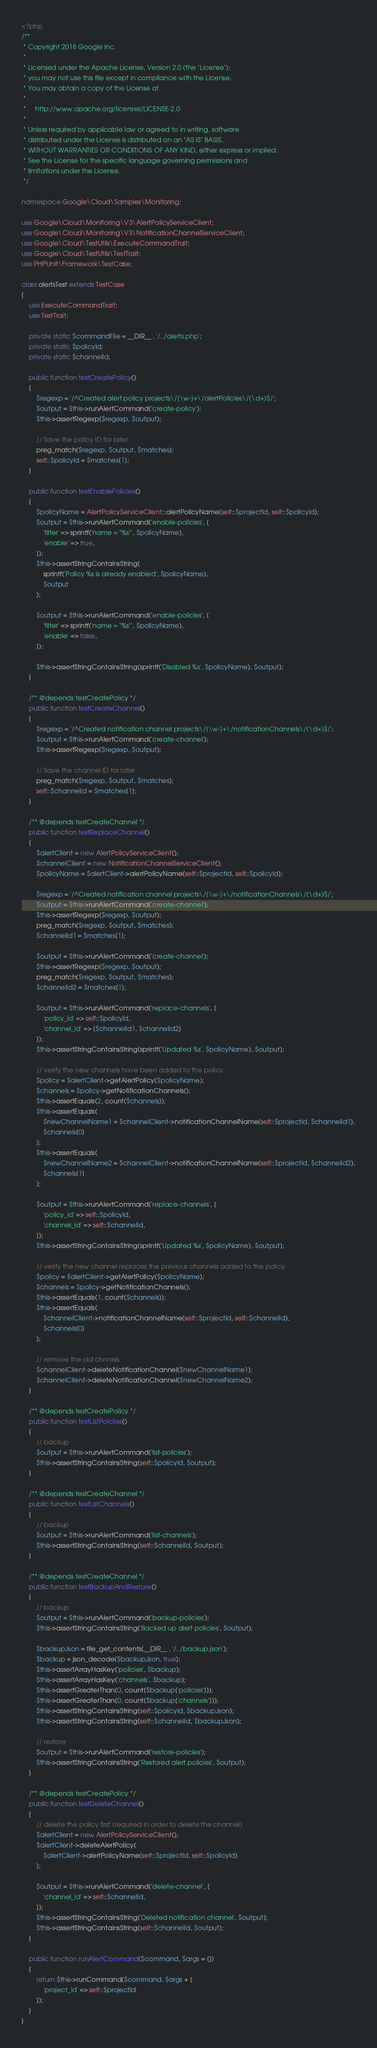<code> <loc_0><loc_0><loc_500><loc_500><_PHP_><?php
/**
 * Copyright 2018 Google Inc.
 *
 * Licensed under the Apache License, Version 2.0 (the "License");
 * you may not use this file except in compliance with the License.
 * You may obtain a copy of the License at
 *
 *     http://www.apache.org/licenses/LICENSE-2.0
 *
 * Unless required by applicable law or agreed to in writing, software
 * distributed under the License is distributed on an "AS IS" BASIS,
 * WITHOUT WARRANTIES OR CONDITIONS OF ANY KIND, either express or implied.
 * See the License for the specific language governing permissions and
 * limitations under the License.
 */

namespace Google\Cloud\Samples\Monitoring;

use Google\Cloud\Monitoring\V3\AlertPolicyServiceClient;
use Google\Cloud\Monitoring\V3\NotificationChannelServiceClient;
use Google\Cloud\TestUtils\ExecuteCommandTrait;
use Google\Cloud\TestUtils\TestTrait;
use PHPUnit\Framework\TestCase;

class alertsTest extends TestCase
{
    use ExecuteCommandTrait;
    use TestTrait;

    private static $commandFile = __DIR__ . '/../alerts.php';
    private static $policyId;
    private static $channelId;

    public function testCreatePolicy()
    {
        $regexp = '/^Created alert policy projects\/[\w-]+\/alertPolicies\/(\d+)$/';
        $output = $this->runAlertCommand('create-policy');
        $this->assertRegexp($regexp, $output);

        // Save the policy ID for later
        preg_match($regexp, $output, $matches);
        self::$policyId = $matches[1];
    }

    public function testEnablePolicies()
    {
        $policyName = AlertPolicyServiceClient::alertPolicyName(self::$projectId, self::$policyId);
        $output = $this->runAlertCommand('enable-policies', [
            'filter' => sprintf('name = "%s"', $policyName),
            'enable' => true,
        ]);
        $this->assertStringContainsString(
            sprintf('Policy %s is already enabled', $policyName),
            $output
        );

        $output = $this->runAlertCommand('enable-policies', [
            'filter' => sprintf('name = "%s"', $policyName),
            'enable' => false,
        ]);

        $this->assertStringContainsString(sprintf('Disabled %s', $policyName), $output);
    }

    /** @depends testCreatePolicy */
    public function testCreateChannel()
    {
        $regexp = '/^Created notification channel projects\/[\w-]+\/notificationChannels\/(\d+)$/';
        $output = $this->runAlertCommand('create-channel');
        $this->assertRegexp($regexp, $output);

        // Save the channel ID for later
        preg_match($regexp, $output, $matches);
        self::$channelId = $matches[1];
    }

    /** @depends testCreateChannel */
    public function testReplaceChannel()
    {
        $alertClient = new AlertPolicyServiceClient();
        $channelClient = new NotificationChannelServiceClient();
        $policyName = $alertClient->alertPolicyName(self::$projectId, self::$policyId);

        $regexp = '/^Created notification channel projects\/[\w-]+\/notificationChannels\/(\d+)$/';
        $output = $this->runAlertCommand('create-channel');
        $this->assertRegexp($regexp, $output);
        preg_match($regexp, $output, $matches);
        $channelId1 = $matches[1];

        $output = $this->runAlertCommand('create-channel');
        $this->assertRegexp($regexp, $output);
        preg_match($regexp, $output, $matches);
        $channelId2 = $matches[1];

        $output = $this->runAlertCommand('replace-channels', [
            'policy_id' => self::$policyId,
            'channel_id' => [$channelId1, $channelId2]
        ]);
        $this->assertStringContainsString(sprintf('Updated %s', $policyName), $output);

        // verify the new channels have been added to the policy
        $policy = $alertClient->getAlertPolicy($policyName);
        $channels = $policy->getNotificationChannels();
        $this->assertEquals(2, count($channels));
        $this->assertEquals(
            $newChannelName1 = $channelClient->notificationChannelName(self::$projectId, $channelId1),
            $channels[0]
        );
        $this->assertEquals(
            $newChannelName2 = $channelClient->notificationChannelName(self::$projectId, $channelId2),
            $channels[1]
        );

        $output = $this->runAlertCommand('replace-channels', [
            'policy_id' => self::$policyId,
            'channel_id' => self::$channelId,
        ]);
        $this->assertStringContainsString(sprintf('Updated %s', $policyName), $output);

        // verify the new channel replaces the previous channels added to the policy
        $policy = $alertClient->getAlertPolicy($policyName);
        $channels = $policy->getNotificationChannels();
        $this->assertEquals(1, count($channels));
        $this->assertEquals(
            $channelClient->notificationChannelName(self::$projectId, self::$channelId),
            $channels[0]
        );

        // remove the old chnnels
        $channelClient->deleteNotificationChannel($newChannelName1);
        $channelClient->deleteNotificationChannel($newChannelName2);
    }

    /** @depends testCreatePolicy */
    public function testListPolciies()
    {
        // backup
        $output = $this->runAlertCommand('list-policies');
        $this->assertStringContainsString(self::$policyId, $output);
    }

    /** @depends testCreateChannel */
    public function testListChannels()
    {
        // backup
        $output = $this->runAlertCommand('list-channels');
        $this->assertStringContainsString(self::$channelId, $output);
    }

    /** @depends testCreateChannel */
    public function testBackupAndRestore()
    {
        // backup
        $output = $this->runAlertCommand('backup-policies');
        $this->assertStringContainsString('Backed up alert policies', $output);

        $backupJson = file_get_contents(__DIR__ . '/../backup.json');
        $backup = json_decode($backupJson, true);
        $this->assertArrayHasKey('policies', $backup);
        $this->assertArrayHasKey('channels', $backup);
        $this->assertGreaterThan(0, count($backup['policies']));
        $this->assertGreaterThan(0, count($backup['channels']));
        $this->assertStringContainsString(self::$policyId, $backupJson);
        $this->assertStringContainsString(self::$channelId, $backupJson);

        // restore
        $output = $this->runAlertCommand('restore-policies');
        $this->assertStringContainsString('Restored alert policies', $output);
    }

    /** @depends testCreatePolicy */
    public function testDeleteChannel()
    {
        // delete the policy first (required in order to delete the channel)
        $alertClient = new AlertPolicyServiceClient();
        $alertClient->deleteAlertPolicy(
            $alertClient->alertPolicyName(self::$projectId, self::$policyId)
        );

        $output = $this->runAlertCommand('delete-channel', [
            'channel_id' => self::$channelId,
        ]);
        $this->assertStringContainsString('Deleted notification channel', $output);
        $this->assertStringContainsString(self::$channelId, $output);
    }

    public function runAlertCommand($command, $args = [])
    {
        return $this->runCommand($command, $args + [
            'project_id' => self::$projectId
        ]);
    }
}
</code> 